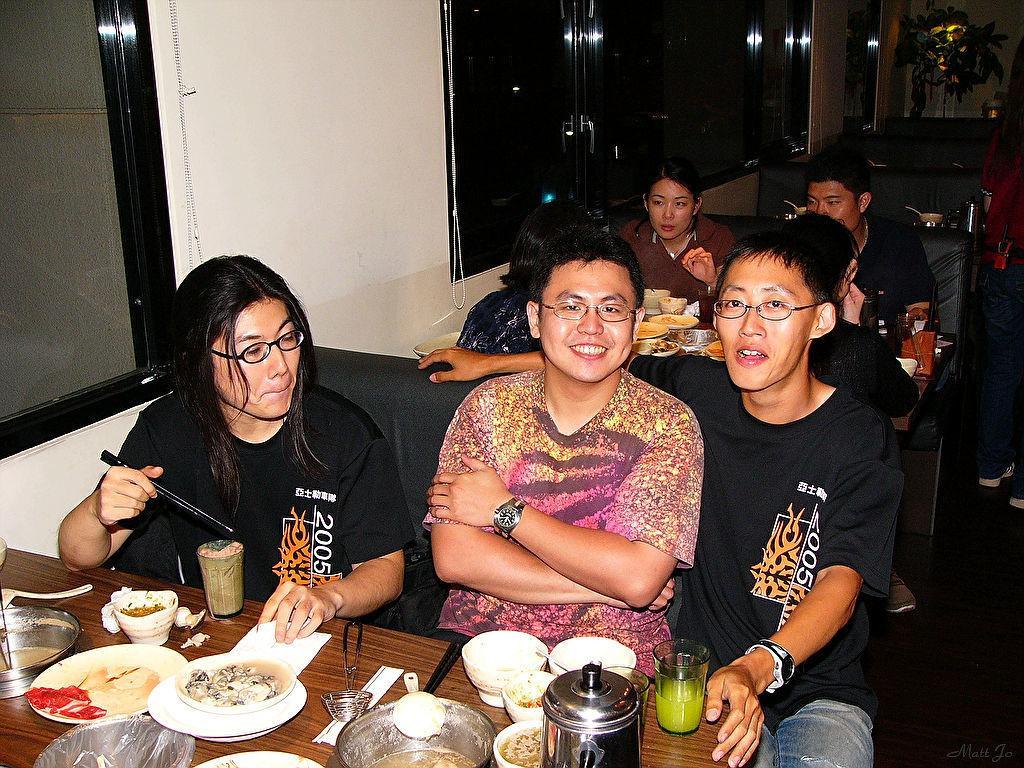Describe this image in one or two sentences. Here in this picture we can see a group of people sitting on sofas with tables in front of them having food items in plates and bowls and we can also see glasses of juice and in the front we can see all the three of them are smiling and beside them we can see windows present and in the far we can see a plant present. 